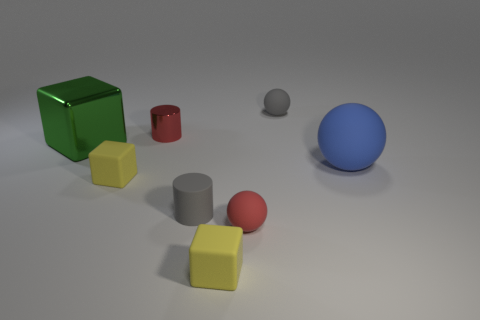Which object in the image looks the softest to the touch? The yellow cube in the image appears to be the softest to the touch, given its light rubber material and edges that lack the sharpness of metal or glass. 